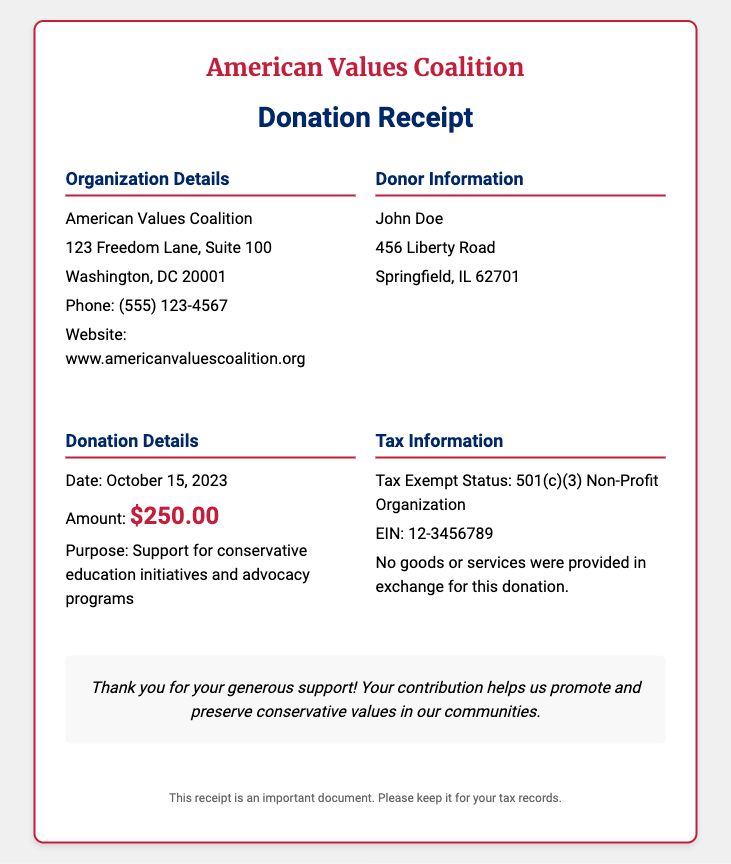What is the name of the organization? The name of the organization is stated at the top of the document in the logo section.
Answer: American Values Coalition What is the donation amount? The donation amount is specified in the Donation Details section, highlighting the financial contribution made.
Answer: $250.00 What was the date of the donation? The date of the donation is mentioned in the Donation Details section, indicating when the contribution was made.
Answer: October 15, 2023 What is the purpose of the donation? The purpose of the donation is detailed in the Donation Details section, explaining the specific program support.
Answer: Support for conservative education initiatives and advocacy programs What is the EIN of the organization? The EIN number is provided in the Tax Information section, which is relevant for tax purposes.
Answer: 12-3456789 How many sections are there in the content area? The number of sections can be counted in the content layout of the document, illustrating its structure.
Answer: Four What type of organization is the American Values Coalition? The type of organization is specified in the Tax Information section, indicating its tax status.
Answer: 501(c)(3) Non-Profit Organization What should you do with this receipt? The instruction on what to do with the receipt is given in the footer, emphasizing its importance.
Answer: Keep it for your tax records How does the organization express gratitude? The expression of gratitude can be found in the thank-you section, reflecting the organization's appreciation for contributions.
Answer: Thank you for your generous support! 